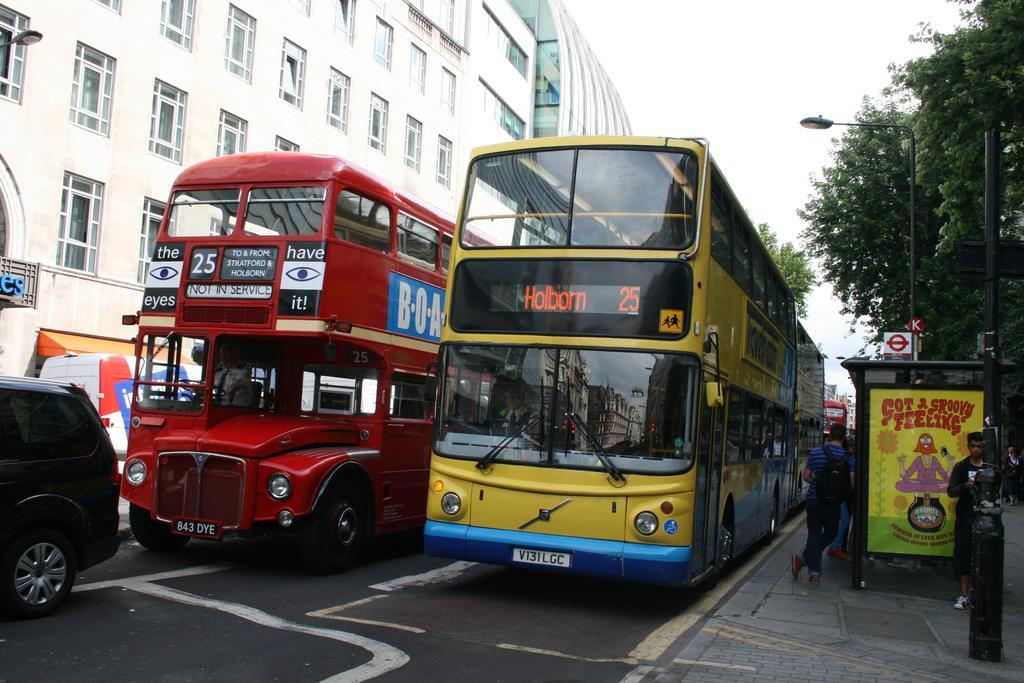Can you describe this image briefly? In this image we can see buses and a vehicle on the road. On the buses there are numbers and text. Inside the buses there are persons. On the right side there is a sidewalk. There are few people. Also there is a banner with text and images. And we can see sign boards. Also there is a light pole and pillar. Also there are trees. On the left side there are buildings with windows. In the background there is sky. 